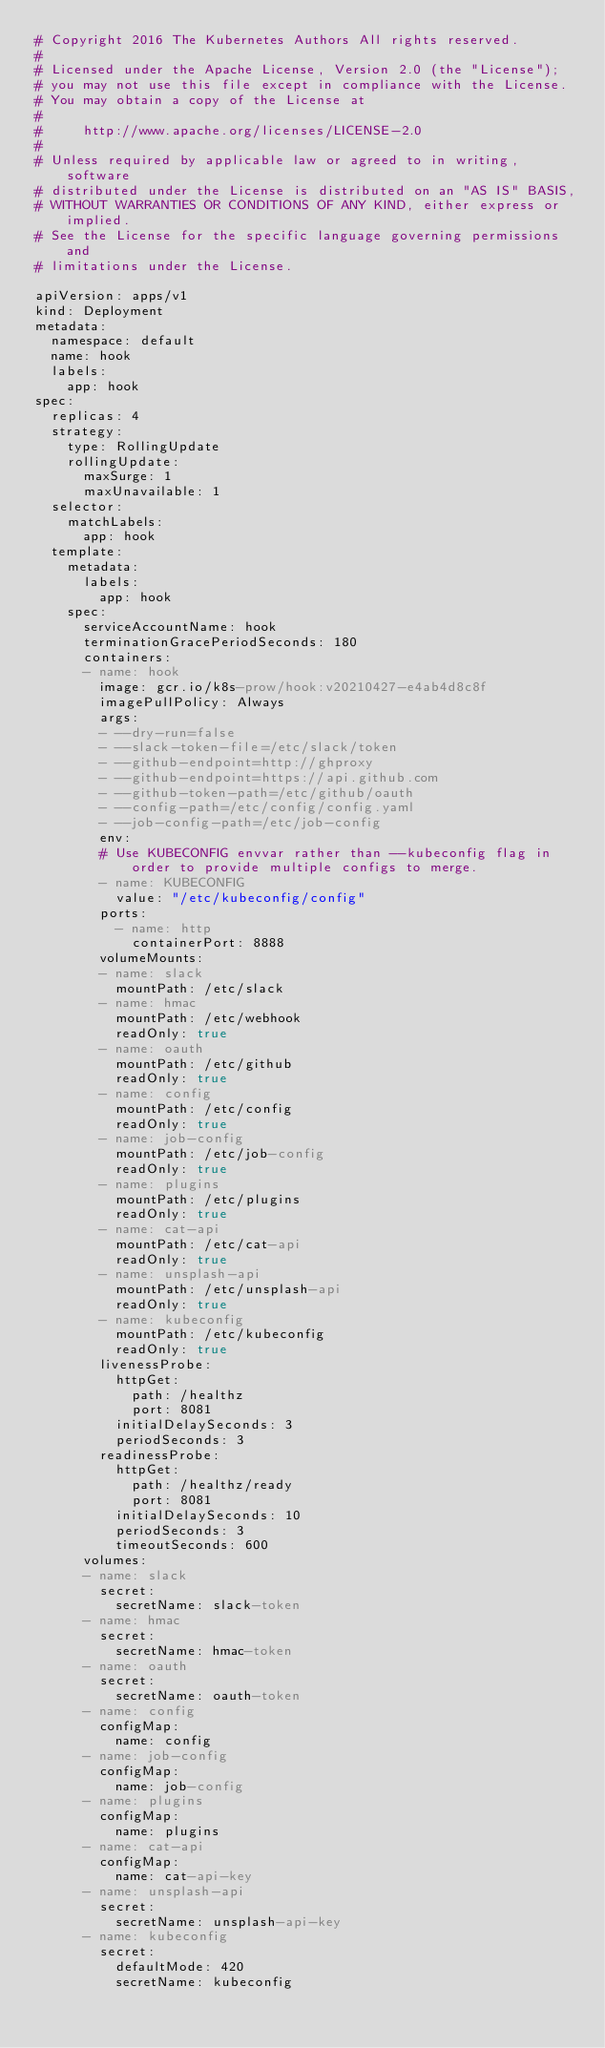<code> <loc_0><loc_0><loc_500><loc_500><_YAML_># Copyright 2016 The Kubernetes Authors All rights reserved.
#
# Licensed under the Apache License, Version 2.0 (the "License");
# you may not use this file except in compliance with the License.
# You may obtain a copy of the License at
#
#     http://www.apache.org/licenses/LICENSE-2.0
#
# Unless required by applicable law or agreed to in writing, software
# distributed under the License is distributed on an "AS IS" BASIS,
# WITHOUT WARRANTIES OR CONDITIONS OF ANY KIND, either express or implied.
# See the License for the specific language governing permissions and
# limitations under the License.

apiVersion: apps/v1
kind: Deployment
metadata:
  namespace: default
  name: hook
  labels:
    app: hook
spec:
  replicas: 4
  strategy:
    type: RollingUpdate
    rollingUpdate:
      maxSurge: 1
      maxUnavailable: 1
  selector:
    matchLabels:
      app: hook
  template:
    metadata:
      labels:
        app: hook
    spec:
      serviceAccountName: hook
      terminationGracePeriodSeconds: 180
      containers:
      - name: hook
        image: gcr.io/k8s-prow/hook:v20210427-e4ab4d8c8f
        imagePullPolicy: Always
        args:
        - --dry-run=false
        - --slack-token-file=/etc/slack/token
        - --github-endpoint=http://ghproxy
        - --github-endpoint=https://api.github.com
        - --github-token-path=/etc/github/oauth
        - --config-path=/etc/config/config.yaml
        - --job-config-path=/etc/job-config
        env:
        # Use KUBECONFIG envvar rather than --kubeconfig flag in order to provide multiple configs to merge.
        - name: KUBECONFIG
          value: "/etc/kubeconfig/config"
        ports:
          - name: http
            containerPort: 8888
        volumeMounts:
        - name: slack
          mountPath: /etc/slack
        - name: hmac
          mountPath: /etc/webhook
          readOnly: true
        - name: oauth
          mountPath: /etc/github
          readOnly: true
        - name: config
          mountPath: /etc/config
          readOnly: true
        - name: job-config
          mountPath: /etc/job-config
          readOnly: true
        - name: plugins
          mountPath: /etc/plugins
          readOnly: true
        - name: cat-api
          mountPath: /etc/cat-api
          readOnly: true
        - name: unsplash-api
          mountPath: /etc/unsplash-api
          readOnly: true
        - name: kubeconfig
          mountPath: /etc/kubeconfig
          readOnly: true
        livenessProbe:
          httpGet:
            path: /healthz
            port: 8081
          initialDelaySeconds: 3
          periodSeconds: 3
        readinessProbe:
          httpGet:
            path: /healthz/ready
            port: 8081
          initialDelaySeconds: 10
          periodSeconds: 3
          timeoutSeconds: 600
      volumes:
      - name: slack
        secret:
          secretName: slack-token
      - name: hmac
        secret:
          secretName: hmac-token
      - name: oauth
        secret:
          secretName: oauth-token
      - name: config
        configMap:
          name: config
      - name: job-config
        configMap:
          name: job-config
      - name: plugins
        configMap:
          name: plugins
      - name: cat-api
        configMap:
          name: cat-api-key
      - name: unsplash-api
        secret:
          secretName: unsplash-api-key
      - name: kubeconfig
        secret:
          defaultMode: 420
          secretName: kubeconfig
</code> 